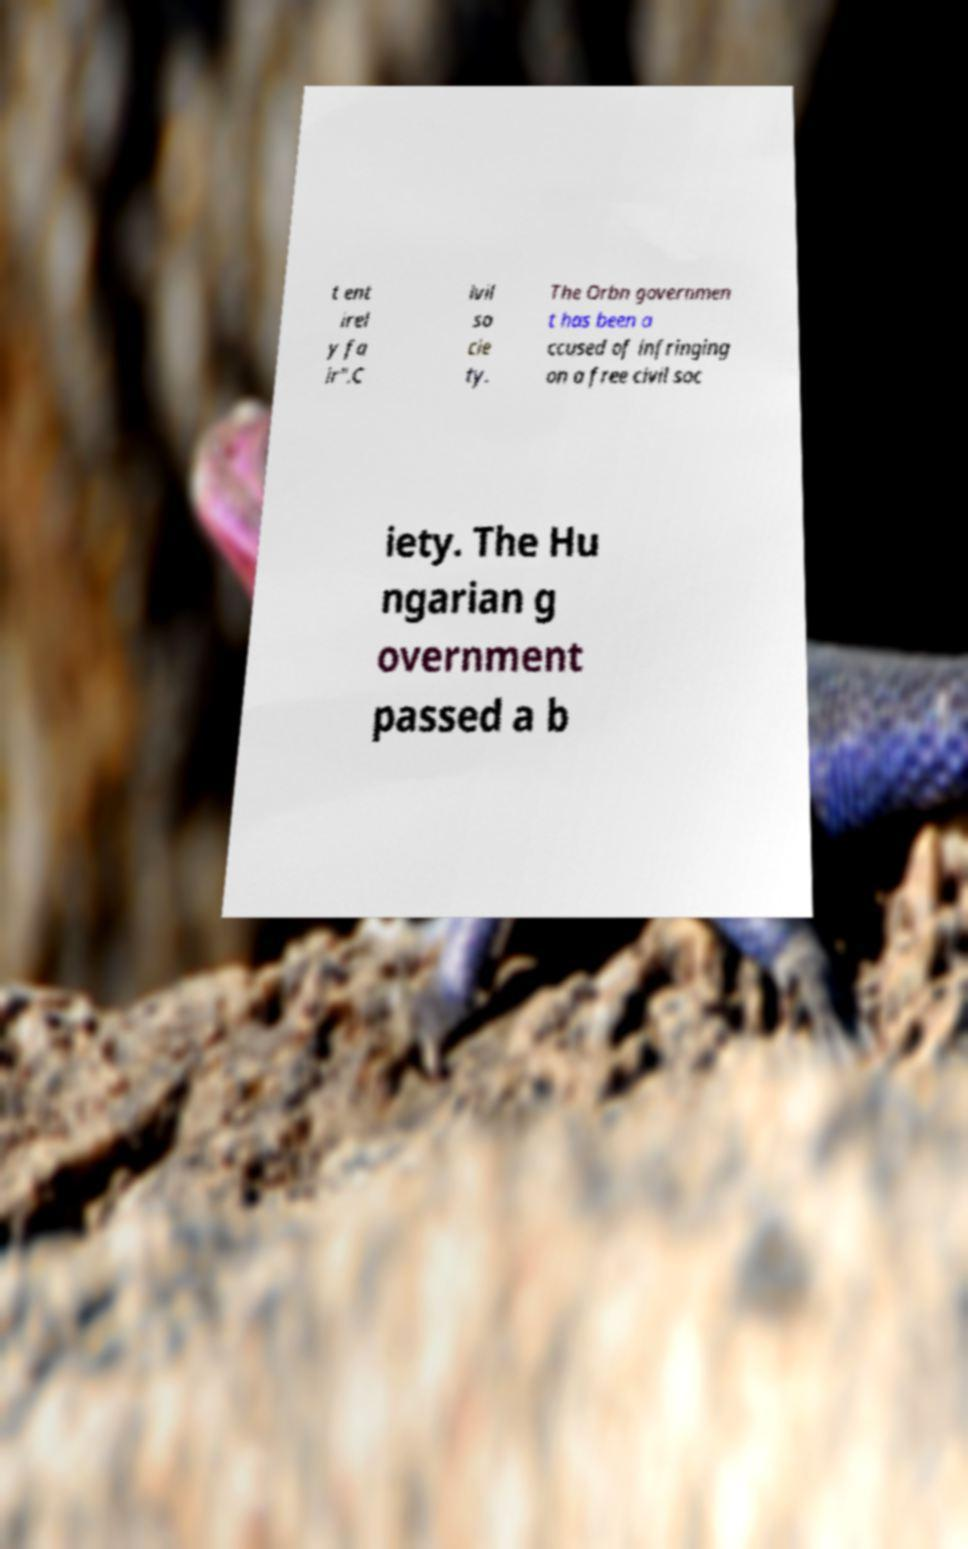Please read and relay the text visible in this image. What does it say? t ent irel y fa ir".C ivil so cie ty. The Orbn governmen t has been a ccused of infringing on a free civil soc iety. The Hu ngarian g overnment passed a b 